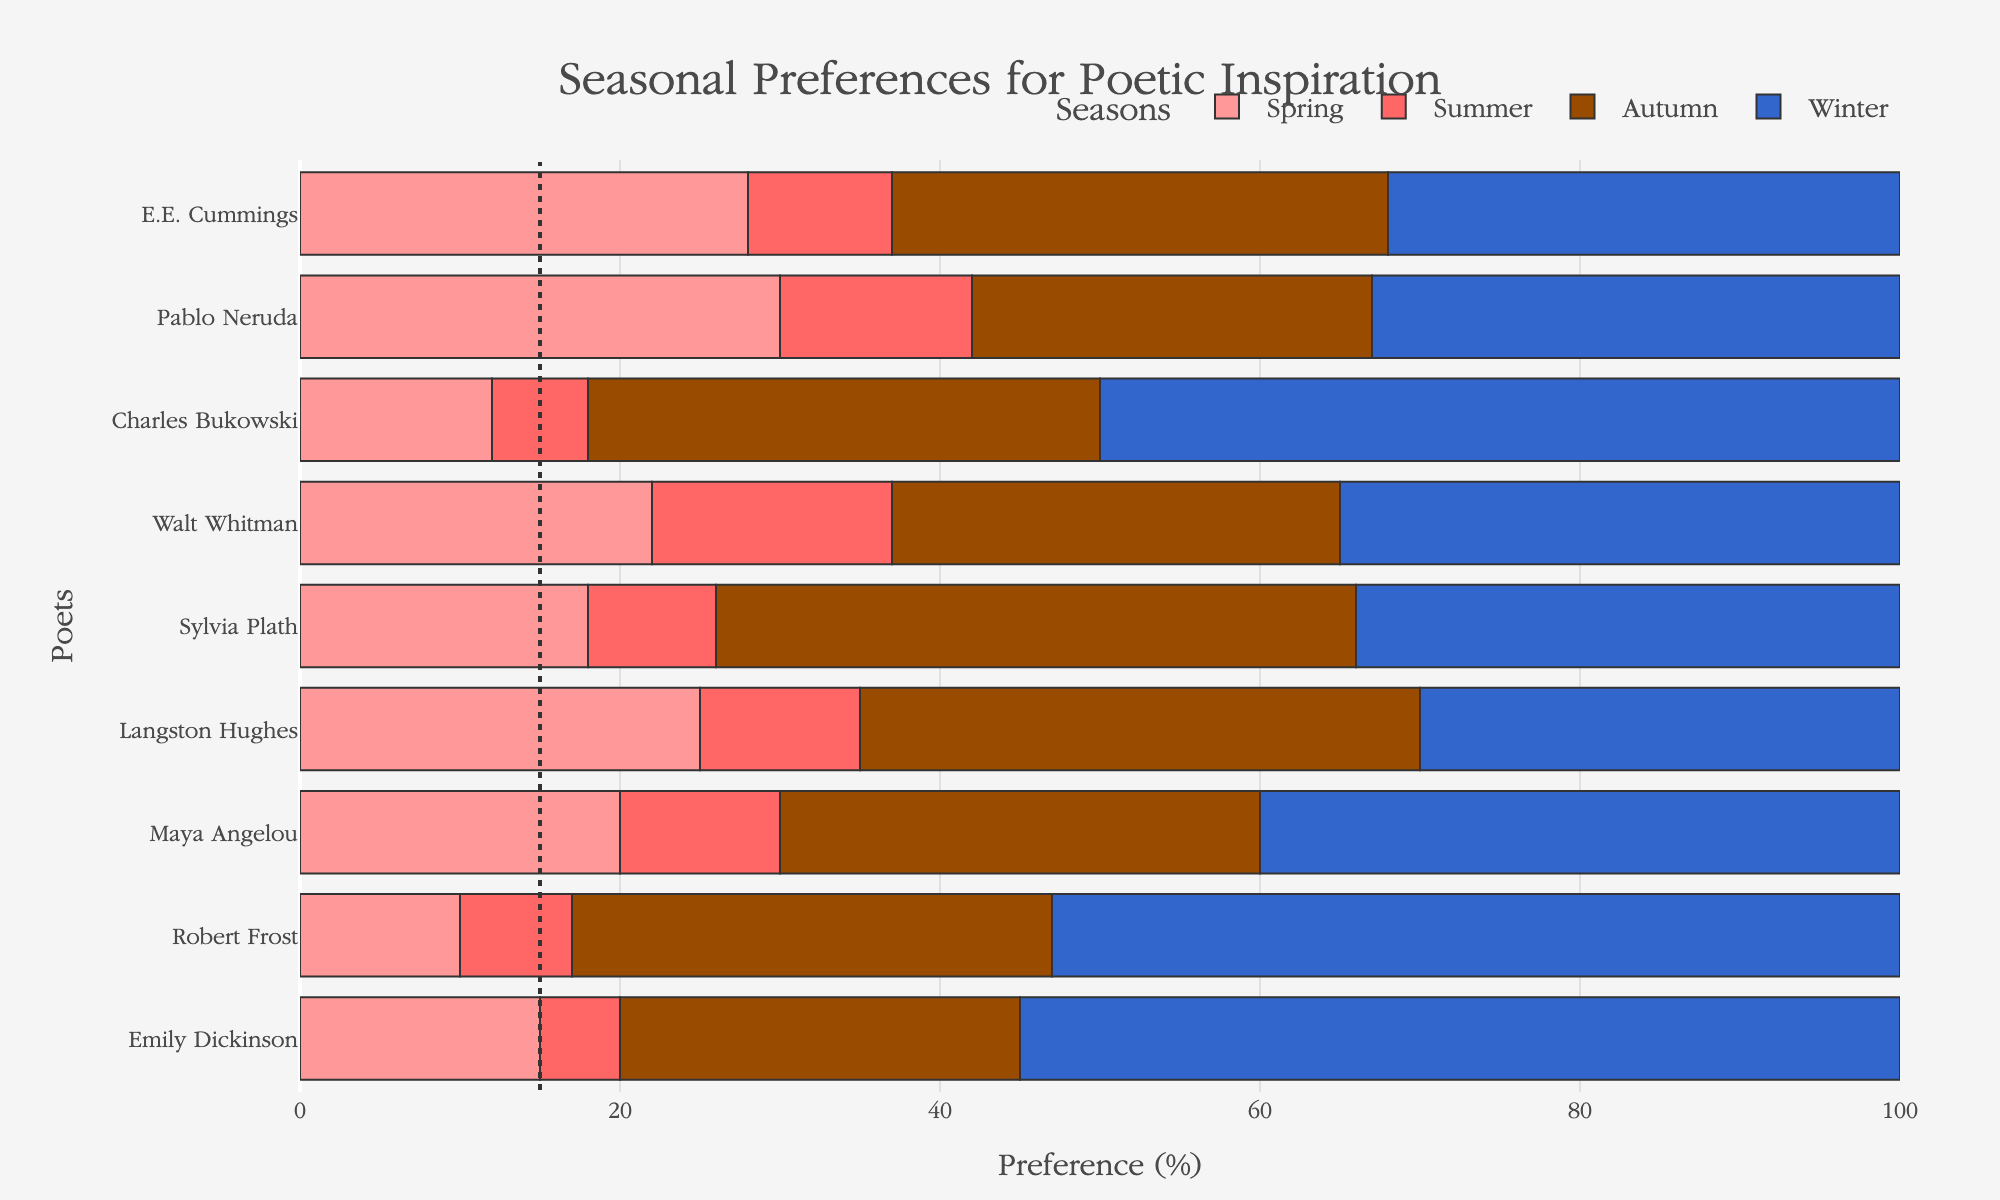Which poet shows the least preference for summer? Observing the lengths of the bars for summer, Charles Bukowski has the shortest bar, indicating he shows the least preference for summer.
Answer: Charles Bukowski Which two poets have the highest preference for autumn? By checking the length of the autumn bars, Sylvia Plath and Langston Hughes both have the highest bars for autumn.
Answer: Sylvia Plath and Langston Hughes What is the combined preference for winter of Robert Frost and Charles Bukowski? The bar lengths for winter for Robert Frost and Charles Bukowski are 53 and 50 respectively. Summing these values gives 53 + 50.
Answer: 103 Which season does Emily Dickinson have the highest preference for? Tracking the bar lengths for Emily Dickinson, the longest bar corresponds to winter.
Answer: Winter How does the preference for spring by Maya Angelou compare to that of Pablo Neruda? The bar length for spring for Maya Angelou is 20, whereas for Pablo Neruda, it is 30. Pablo Neruda shows a higher preference.
Answer: Pablo Neruda What is the average preference for summer amongst all poets? Adding up all values for summer (5 + 7 + 10 + 10 + 8 + 15 + 6 + 12 + 9 = 82), then dividing by the number of poets (9). 82/9 ≈ 9.11
Answer: 9.11 Which poet shows the greatest variability in their seasonal preferences? The poet with the most diverse bar lengths across seasons shows the greatest variability. Emily Dickinson's preferences range from 5 to 55, indicating high variability.
Answer: Emily Dickinson Which poets prefer autumn over winter? By comparing the bar lengths of autumn and winter, only Sylvia Plath and Langston Hughes have longer bars for autumn than for winter.
Answer: Sylvia Plath and Langston Hughes 